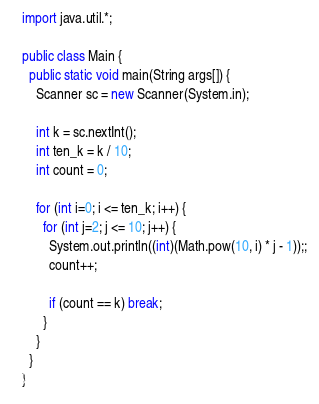<code> <loc_0><loc_0><loc_500><loc_500><_Java_>import java.util.*;

public class Main {
  public static void main(String args[]) {
    Scanner sc = new Scanner(System.in);

    int k = sc.nextInt();
    int ten_k = k / 10;
    int count = 0;

    for (int i=0; i <= ten_k; i++) {
      for (int j=2; j <= 10; j++) {
        System.out.println((int)(Math.pow(10, i) * j - 1));;
        count++;

        if (count == k) break;
      }
    }
  }
}
</code> 